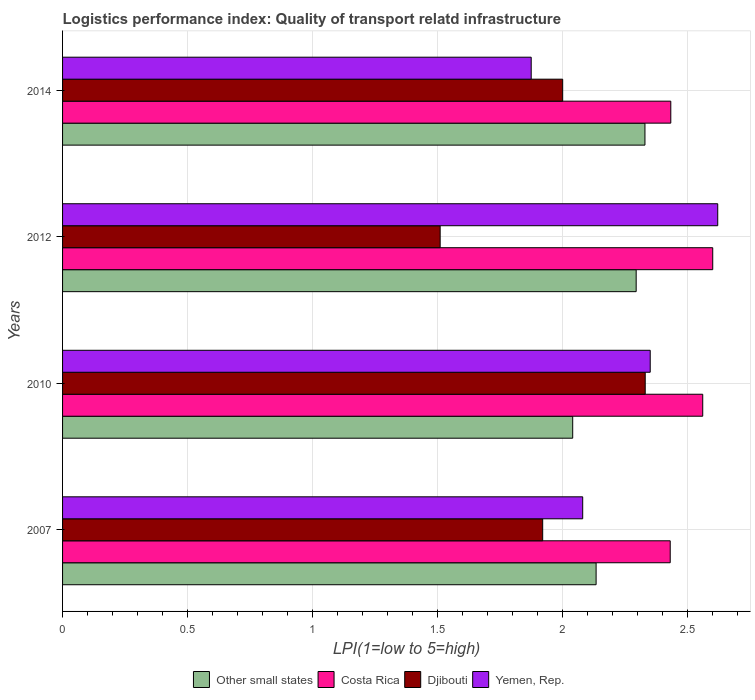How many bars are there on the 3rd tick from the bottom?
Provide a succinct answer. 4. What is the label of the 3rd group of bars from the top?
Offer a terse response. 2010. In how many cases, is the number of bars for a given year not equal to the number of legend labels?
Your answer should be compact. 0. What is the logistics performance index in Other small states in 2010?
Your answer should be compact. 2.04. Across all years, what is the maximum logistics performance index in Yemen, Rep.?
Make the answer very short. 2.62. Across all years, what is the minimum logistics performance index in Yemen, Rep.?
Offer a very short reply. 1.87. In which year was the logistics performance index in Djibouti maximum?
Keep it short and to the point. 2010. In which year was the logistics performance index in Other small states minimum?
Ensure brevity in your answer.  2010. What is the total logistics performance index in Costa Rica in the graph?
Make the answer very short. 10.02. What is the difference between the logistics performance index in Costa Rica in 2007 and that in 2014?
Your answer should be compact. -0. What is the difference between the logistics performance index in Other small states in 2010 and the logistics performance index in Costa Rica in 2012?
Give a very brief answer. -0.56. What is the average logistics performance index in Yemen, Rep. per year?
Ensure brevity in your answer.  2.23. In the year 2007, what is the difference between the logistics performance index in Yemen, Rep. and logistics performance index in Costa Rica?
Your answer should be very brief. -0.35. In how many years, is the logistics performance index in Other small states greater than 2.5 ?
Provide a short and direct response. 0. What is the ratio of the logistics performance index in Costa Rica in 2007 to that in 2010?
Offer a terse response. 0.95. What is the difference between the highest and the second highest logistics performance index in Yemen, Rep.?
Provide a succinct answer. 0.27. What is the difference between the highest and the lowest logistics performance index in Djibouti?
Your answer should be compact. 0.82. In how many years, is the logistics performance index in Yemen, Rep. greater than the average logistics performance index in Yemen, Rep. taken over all years?
Your answer should be very brief. 2. Is the sum of the logistics performance index in Yemen, Rep. in 2007 and 2010 greater than the maximum logistics performance index in Costa Rica across all years?
Provide a succinct answer. Yes. What does the 4th bar from the top in 2014 represents?
Offer a very short reply. Other small states. What does the 1st bar from the bottom in 2014 represents?
Offer a very short reply. Other small states. How many bars are there?
Your response must be concise. 16. How many years are there in the graph?
Your answer should be very brief. 4. Are the values on the major ticks of X-axis written in scientific E-notation?
Offer a very short reply. No. Does the graph contain grids?
Keep it short and to the point. Yes. What is the title of the graph?
Make the answer very short. Logistics performance index: Quality of transport relatd infrastructure. Does "Panama" appear as one of the legend labels in the graph?
Your answer should be very brief. No. What is the label or title of the X-axis?
Ensure brevity in your answer.  LPI(1=low to 5=high). What is the LPI(1=low to 5=high) in Other small states in 2007?
Provide a short and direct response. 2.13. What is the LPI(1=low to 5=high) in Costa Rica in 2007?
Offer a terse response. 2.43. What is the LPI(1=low to 5=high) of Djibouti in 2007?
Your answer should be compact. 1.92. What is the LPI(1=low to 5=high) of Yemen, Rep. in 2007?
Keep it short and to the point. 2.08. What is the LPI(1=low to 5=high) of Other small states in 2010?
Give a very brief answer. 2.04. What is the LPI(1=low to 5=high) of Costa Rica in 2010?
Make the answer very short. 2.56. What is the LPI(1=low to 5=high) of Djibouti in 2010?
Provide a short and direct response. 2.33. What is the LPI(1=low to 5=high) in Yemen, Rep. in 2010?
Your response must be concise. 2.35. What is the LPI(1=low to 5=high) of Other small states in 2012?
Offer a very short reply. 2.29. What is the LPI(1=low to 5=high) in Djibouti in 2012?
Provide a succinct answer. 1.51. What is the LPI(1=low to 5=high) in Yemen, Rep. in 2012?
Your answer should be compact. 2.62. What is the LPI(1=low to 5=high) of Other small states in 2014?
Your answer should be compact. 2.33. What is the LPI(1=low to 5=high) in Costa Rica in 2014?
Give a very brief answer. 2.43. What is the LPI(1=low to 5=high) of Djibouti in 2014?
Your response must be concise. 2. What is the LPI(1=low to 5=high) of Yemen, Rep. in 2014?
Make the answer very short. 1.87. Across all years, what is the maximum LPI(1=low to 5=high) in Other small states?
Provide a succinct answer. 2.33. Across all years, what is the maximum LPI(1=low to 5=high) in Costa Rica?
Your response must be concise. 2.6. Across all years, what is the maximum LPI(1=low to 5=high) of Djibouti?
Offer a very short reply. 2.33. Across all years, what is the maximum LPI(1=low to 5=high) of Yemen, Rep.?
Provide a short and direct response. 2.62. Across all years, what is the minimum LPI(1=low to 5=high) of Other small states?
Keep it short and to the point. 2.04. Across all years, what is the minimum LPI(1=low to 5=high) of Costa Rica?
Your answer should be compact. 2.43. Across all years, what is the minimum LPI(1=low to 5=high) of Djibouti?
Offer a very short reply. 1.51. Across all years, what is the minimum LPI(1=low to 5=high) in Yemen, Rep.?
Your response must be concise. 1.87. What is the total LPI(1=low to 5=high) of Other small states in the graph?
Offer a terse response. 8.8. What is the total LPI(1=low to 5=high) in Costa Rica in the graph?
Offer a terse response. 10.02. What is the total LPI(1=low to 5=high) of Djibouti in the graph?
Give a very brief answer. 7.76. What is the total LPI(1=low to 5=high) of Yemen, Rep. in the graph?
Provide a short and direct response. 8.92. What is the difference between the LPI(1=low to 5=high) of Other small states in 2007 and that in 2010?
Ensure brevity in your answer.  0.09. What is the difference between the LPI(1=low to 5=high) in Costa Rica in 2007 and that in 2010?
Offer a very short reply. -0.13. What is the difference between the LPI(1=low to 5=high) in Djibouti in 2007 and that in 2010?
Offer a very short reply. -0.41. What is the difference between the LPI(1=low to 5=high) in Yemen, Rep. in 2007 and that in 2010?
Make the answer very short. -0.27. What is the difference between the LPI(1=low to 5=high) in Other small states in 2007 and that in 2012?
Your response must be concise. -0.16. What is the difference between the LPI(1=low to 5=high) in Costa Rica in 2007 and that in 2012?
Make the answer very short. -0.17. What is the difference between the LPI(1=low to 5=high) in Djibouti in 2007 and that in 2012?
Offer a very short reply. 0.41. What is the difference between the LPI(1=low to 5=high) in Yemen, Rep. in 2007 and that in 2012?
Your answer should be compact. -0.54. What is the difference between the LPI(1=low to 5=high) in Other small states in 2007 and that in 2014?
Provide a succinct answer. -0.2. What is the difference between the LPI(1=low to 5=high) of Costa Rica in 2007 and that in 2014?
Provide a succinct answer. -0. What is the difference between the LPI(1=low to 5=high) of Djibouti in 2007 and that in 2014?
Your answer should be very brief. -0.08. What is the difference between the LPI(1=low to 5=high) in Yemen, Rep. in 2007 and that in 2014?
Offer a terse response. 0.21. What is the difference between the LPI(1=low to 5=high) of Other small states in 2010 and that in 2012?
Provide a succinct answer. -0.25. What is the difference between the LPI(1=low to 5=high) in Costa Rica in 2010 and that in 2012?
Give a very brief answer. -0.04. What is the difference between the LPI(1=low to 5=high) in Djibouti in 2010 and that in 2012?
Offer a very short reply. 0.82. What is the difference between the LPI(1=low to 5=high) in Yemen, Rep. in 2010 and that in 2012?
Provide a succinct answer. -0.27. What is the difference between the LPI(1=low to 5=high) in Other small states in 2010 and that in 2014?
Offer a terse response. -0.29. What is the difference between the LPI(1=low to 5=high) in Costa Rica in 2010 and that in 2014?
Ensure brevity in your answer.  0.13. What is the difference between the LPI(1=low to 5=high) of Djibouti in 2010 and that in 2014?
Keep it short and to the point. 0.33. What is the difference between the LPI(1=low to 5=high) in Yemen, Rep. in 2010 and that in 2014?
Provide a succinct answer. 0.48. What is the difference between the LPI(1=low to 5=high) of Other small states in 2012 and that in 2014?
Your answer should be compact. -0.04. What is the difference between the LPI(1=low to 5=high) of Costa Rica in 2012 and that in 2014?
Provide a succinct answer. 0.17. What is the difference between the LPI(1=low to 5=high) of Djibouti in 2012 and that in 2014?
Make the answer very short. -0.49. What is the difference between the LPI(1=low to 5=high) in Yemen, Rep. in 2012 and that in 2014?
Ensure brevity in your answer.  0.75. What is the difference between the LPI(1=low to 5=high) of Other small states in 2007 and the LPI(1=low to 5=high) of Costa Rica in 2010?
Provide a succinct answer. -0.43. What is the difference between the LPI(1=low to 5=high) in Other small states in 2007 and the LPI(1=low to 5=high) in Djibouti in 2010?
Give a very brief answer. -0.2. What is the difference between the LPI(1=low to 5=high) in Other small states in 2007 and the LPI(1=low to 5=high) in Yemen, Rep. in 2010?
Provide a succinct answer. -0.22. What is the difference between the LPI(1=low to 5=high) in Djibouti in 2007 and the LPI(1=low to 5=high) in Yemen, Rep. in 2010?
Make the answer very short. -0.43. What is the difference between the LPI(1=low to 5=high) in Other small states in 2007 and the LPI(1=low to 5=high) in Costa Rica in 2012?
Ensure brevity in your answer.  -0.47. What is the difference between the LPI(1=low to 5=high) of Other small states in 2007 and the LPI(1=low to 5=high) of Djibouti in 2012?
Offer a very short reply. 0.62. What is the difference between the LPI(1=low to 5=high) in Other small states in 2007 and the LPI(1=low to 5=high) in Yemen, Rep. in 2012?
Your answer should be compact. -0.49. What is the difference between the LPI(1=low to 5=high) in Costa Rica in 2007 and the LPI(1=low to 5=high) in Yemen, Rep. in 2012?
Offer a very short reply. -0.19. What is the difference between the LPI(1=low to 5=high) in Djibouti in 2007 and the LPI(1=low to 5=high) in Yemen, Rep. in 2012?
Give a very brief answer. -0.7. What is the difference between the LPI(1=low to 5=high) in Other small states in 2007 and the LPI(1=low to 5=high) in Costa Rica in 2014?
Make the answer very short. -0.3. What is the difference between the LPI(1=low to 5=high) in Other small states in 2007 and the LPI(1=low to 5=high) in Djibouti in 2014?
Offer a very short reply. 0.13. What is the difference between the LPI(1=low to 5=high) in Other small states in 2007 and the LPI(1=low to 5=high) in Yemen, Rep. in 2014?
Give a very brief answer. 0.26. What is the difference between the LPI(1=low to 5=high) of Costa Rica in 2007 and the LPI(1=low to 5=high) of Djibouti in 2014?
Your response must be concise. 0.43. What is the difference between the LPI(1=low to 5=high) of Costa Rica in 2007 and the LPI(1=low to 5=high) of Yemen, Rep. in 2014?
Make the answer very short. 0.56. What is the difference between the LPI(1=low to 5=high) in Djibouti in 2007 and the LPI(1=low to 5=high) in Yemen, Rep. in 2014?
Provide a short and direct response. 0.05. What is the difference between the LPI(1=low to 5=high) of Other small states in 2010 and the LPI(1=low to 5=high) of Costa Rica in 2012?
Provide a short and direct response. -0.56. What is the difference between the LPI(1=low to 5=high) of Other small states in 2010 and the LPI(1=low to 5=high) of Djibouti in 2012?
Give a very brief answer. 0.53. What is the difference between the LPI(1=low to 5=high) in Other small states in 2010 and the LPI(1=low to 5=high) in Yemen, Rep. in 2012?
Offer a very short reply. -0.58. What is the difference between the LPI(1=low to 5=high) of Costa Rica in 2010 and the LPI(1=low to 5=high) of Djibouti in 2012?
Provide a succinct answer. 1.05. What is the difference between the LPI(1=low to 5=high) in Costa Rica in 2010 and the LPI(1=low to 5=high) in Yemen, Rep. in 2012?
Give a very brief answer. -0.06. What is the difference between the LPI(1=low to 5=high) in Djibouti in 2010 and the LPI(1=low to 5=high) in Yemen, Rep. in 2012?
Your answer should be compact. -0.29. What is the difference between the LPI(1=low to 5=high) in Other small states in 2010 and the LPI(1=low to 5=high) in Costa Rica in 2014?
Offer a terse response. -0.39. What is the difference between the LPI(1=low to 5=high) in Other small states in 2010 and the LPI(1=low to 5=high) in Djibouti in 2014?
Offer a very short reply. 0.04. What is the difference between the LPI(1=low to 5=high) in Other small states in 2010 and the LPI(1=low to 5=high) in Yemen, Rep. in 2014?
Your answer should be very brief. 0.17. What is the difference between the LPI(1=low to 5=high) of Costa Rica in 2010 and the LPI(1=low to 5=high) of Djibouti in 2014?
Give a very brief answer. 0.56. What is the difference between the LPI(1=low to 5=high) in Costa Rica in 2010 and the LPI(1=low to 5=high) in Yemen, Rep. in 2014?
Your answer should be compact. 0.69. What is the difference between the LPI(1=low to 5=high) of Djibouti in 2010 and the LPI(1=low to 5=high) of Yemen, Rep. in 2014?
Your answer should be very brief. 0.46. What is the difference between the LPI(1=low to 5=high) in Other small states in 2012 and the LPI(1=low to 5=high) in Costa Rica in 2014?
Your answer should be very brief. -0.14. What is the difference between the LPI(1=low to 5=high) of Other small states in 2012 and the LPI(1=low to 5=high) of Djibouti in 2014?
Your answer should be very brief. 0.29. What is the difference between the LPI(1=low to 5=high) of Other small states in 2012 and the LPI(1=low to 5=high) of Yemen, Rep. in 2014?
Your answer should be very brief. 0.42. What is the difference between the LPI(1=low to 5=high) of Costa Rica in 2012 and the LPI(1=low to 5=high) of Yemen, Rep. in 2014?
Provide a short and direct response. 0.73. What is the difference between the LPI(1=low to 5=high) of Djibouti in 2012 and the LPI(1=low to 5=high) of Yemen, Rep. in 2014?
Provide a succinct answer. -0.36. What is the average LPI(1=low to 5=high) of Other small states per year?
Ensure brevity in your answer.  2.2. What is the average LPI(1=low to 5=high) in Costa Rica per year?
Your answer should be very brief. 2.51. What is the average LPI(1=low to 5=high) in Djibouti per year?
Your response must be concise. 1.94. What is the average LPI(1=low to 5=high) in Yemen, Rep. per year?
Ensure brevity in your answer.  2.23. In the year 2007, what is the difference between the LPI(1=low to 5=high) in Other small states and LPI(1=low to 5=high) in Costa Rica?
Give a very brief answer. -0.3. In the year 2007, what is the difference between the LPI(1=low to 5=high) in Other small states and LPI(1=low to 5=high) in Djibouti?
Your response must be concise. 0.21. In the year 2007, what is the difference between the LPI(1=low to 5=high) in Other small states and LPI(1=low to 5=high) in Yemen, Rep.?
Offer a terse response. 0.05. In the year 2007, what is the difference between the LPI(1=low to 5=high) of Costa Rica and LPI(1=low to 5=high) of Djibouti?
Provide a succinct answer. 0.51. In the year 2007, what is the difference between the LPI(1=low to 5=high) in Djibouti and LPI(1=low to 5=high) in Yemen, Rep.?
Make the answer very short. -0.16. In the year 2010, what is the difference between the LPI(1=low to 5=high) in Other small states and LPI(1=low to 5=high) in Costa Rica?
Your answer should be compact. -0.52. In the year 2010, what is the difference between the LPI(1=low to 5=high) of Other small states and LPI(1=low to 5=high) of Djibouti?
Provide a succinct answer. -0.29. In the year 2010, what is the difference between the LPI(1=low to 5=high) in Other small states and LPI(1=low to 5=high) in Yemen, Rep.?
Ensure brevity in your answer.  -0.31. In the year 2010, what is the difference between the LPI(1=low to 5=high) of Costa Rica and LPI(1=low to 5=high) of Djibouti?
Your answer should be very brief. 0.23. In the year 2010, what is the difference between the LPI(1=low to 5=high) of Costa Rica and LPI(1=low to 5=high) of Yemen, Rep.?
Ensure brevity in your answer.  0.21. In the year 2010, what is the difference between the LPI(1=low to 5=high) in Djibouti and LPI(1=low to 5=high) in Yemen, Rep.?
Your response must be concise. -0.02. In the year 2012, what is the difference between the LPI(1=low to 5=high) in Other small states and LPI(1=low to 5=high) in Costa Rica?
Your answer should be compact. -0.31. In the year 2012, what is the difference between the LPI(1=low to 5=high) of Other small states and LPI(1=low to 5=high) of Djibouti?
Your answer should be very brief. 0.78. In the year 2012, what is the difference between the LPI(1=low to 5=high) of Other small states and LPI(1=low to 5=high) of Yemen, Rep.?
Your answer should be compact. -0.33. In the year 2012, what is the difference between the LPI(1=low to 5=high) of Costa Rica and LPI(1=low to 5=high) of Djibouti?
Give a very brief answer. 1.09. In the year 2012, what is the difference between the LPI(1=low to 5=high) in Costa Rica and LPI(1=low to 5=high) in Yemen, Rep.?
Your answer should be very brief. -0.02. In the year 2012, what is the difference between the LPI(1=low to 5=high) of Djibouti and LPI(1=low to 5=high) of Yemen, Rep.?
Offer a very short reply. -1.11. In the year 2014, what is the difference between the LPI(1=low to 5=high) in Other small states and LPI(1=low to 5=high) in Costa Rica?
Offer a very short reply. -0.1. In the year 2014, what is the difference between the LPI(1=low to 5=high) in Other small states and LPI(1=low to 5=high) in Djibouti?
Give a very brief answer. 0.33. In the year 2014, what is the difference between the LPI(1=low to 5=high) in Other small states and LPI(1=low to 5=high) in Yemen, Rep.?
Provide a short and direct response. 0.45. In the year 2014, what is the difference between the LPI(1=low to 5=high) in Costa Rica and LPI(1=low to 5=high) in Djibouti?
Keep it short and to the point. 0.43. In the year 2014, what is the difference between the LPI(1=low to 5=high) in Costa Rica and LPI(1=low to 5=high) in Yemen, Rep.?
Your response must be concise. 0.56. In the year 2014, what is the difference between the LPI(1=low to 5=high) in Djibouti and LPI(1=low to 5=high) in Yemen, Rep.?
Give a very brief answer. 0.13. What is the ratio of the LPI(1=low to 5=high) in Other small states in 2007 to that in 2010?
Offer a very short reply. 1.05. What is the ratio of the LPI(1=low to 5=high) of Costa Rica in 2007 to that in 2010?
Ensure brevity in your answer.  0.95. What is the ratio of the LPI(1=low to 5=high) of Djibouti in 2007 to that in 2010?
Your answer should be very brief. 0.82. What is the ratio of the LPI(1=low to 5=high) of Yemen, Rep. in 2007 to that in 2010?
Your answer should be very brief. 0.89. What is the ratio of the LPI(1=low to 5=high) in Other small states in 2007 to that in 2012?
Give a very brief answer. 0.93. What is the ratio of the LPI(1=low to 5=high) of Costa Rica in 2007 to that in 2012?
Provide a succinct answer. 0.93. What is the ratio of the LPI(1=low to 5=high) in Djibouti in 2007 to that in 2012?
Offer a very short reply. 1.27. What is the ratio of the LPI(1=low to 5=high) in Yemen, Rep. in 2007 to that in 2012?
Make the answer very short. 0.79. What is the ratio of the LPI(1=low to 5=high) in Other small states in 2007 to that in 2014?
Give a very brief answer. 0.92. What is the ratio of the LPI(1=low to 5=high) in Djibouti in 2007 to that in 2014?
Provide a short and direct response. 0.96. What is the ratio of the LPI(1=low to 5=high) of Yemen, Rep. in 2007 to that in 2014?
Offer a terse response. 1.11. What is the ratio of the LPI(1=low to 5=high) in Other small states in 2010 to that in 2012?
Give a very brief answer. 0.89. What is the ratio of the LPI(1=low to 5=high) of Costa Rica in 2010 to that in 2012?
Your answer should be very brief. 0.98. What is the ratio of the LPI(1=low to 5=high) of Djibouti in 2010 to that in 2012?
Your answer should be compact. 1.54. What is the ratio of the LPI(1=low to 5=high) in Yemen, Rep. in 2010 to that in 2012?
Give a very brief answer. 0.9. What is the ratio of the LPI(1=low to 5=high) of Other small states in 2010 to that in 2014?
Offer a terse response. 0.88. What is the ratio of the LPI(1=low to 5=high) of Costa Rica in 2010 to that in 2014?
Your answer should be compact. 1.05. What is the ratio of the LPI(1=low to 5=high) of Djibouti in 2010 to that in 2014?
Provide a short and direct response. 1.17. What is the ratio of the LPI(1=low to 5=high) of Yemen, Rep. in 2010 to that in 2014?
Provide a short and direct response. 1.25. What is the ratio of the LPI(1=low to 5=high) in Other small states in 2012 to that in 2014?
Give a very brief answer. 0.98. What is the ratio of the LPI(1=low to 5=high) in Costa Rica in 2012 to that in 2014?
Keep it short and to the point. 1.07. What is the ratio of the LPI(1=low to 5=high) in Djibouti in 2012 to that in 2014?
Offer a very short reply. 0.76. What is the ratio of the LPI(1=low to 5=high) of Yemen, Rep. in 2012 to that in 2014?
Provide a short and direct response. 1.4. What is the difference between the highest and the second highest LPI(1=low to 5=high) of Other small states?
Provide a succinct answer. 0.04. What is the difference between the highest and the second highest LPI(1=low to 5=high) in Djibouti?
Provide a succinct answer. 0.33. What is the difference between the highest and the second highest LPI(1=low to 5=high) in Yemen, Rep.?
Your answer should be very brief. 0.27. What is the difference between the highest and the lowest LPI(1=low to 5=high) in Other small states?
Keep it short and to the point. 0.29. What is the difference between the highest and the lowest LPI(1=low to 5=high) of Costa Rica?
Offer a terse response. 0.17. What is the difference between the highest and the lowest LPI(1=low to 5=high) of Djibouti?
Ensure brevity in your answer.  0.82. What is the difference between the highest and the lowest LPI(1=low to 5=high) of Yemen, Rep.?
Make the answer very short. 0.75. 